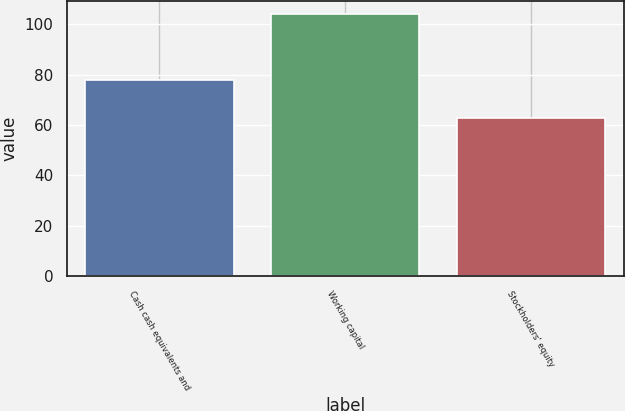Convert chart to OTSL. <chart><loc_0><loc_0><loc_500><loc_500><bar_chart><fcel>Cash cash equivalents and<fcel>Working capital<fcel>Stockholders' equity<nl><fcel>78<fcel>104<fcel>63<nl></chart> 